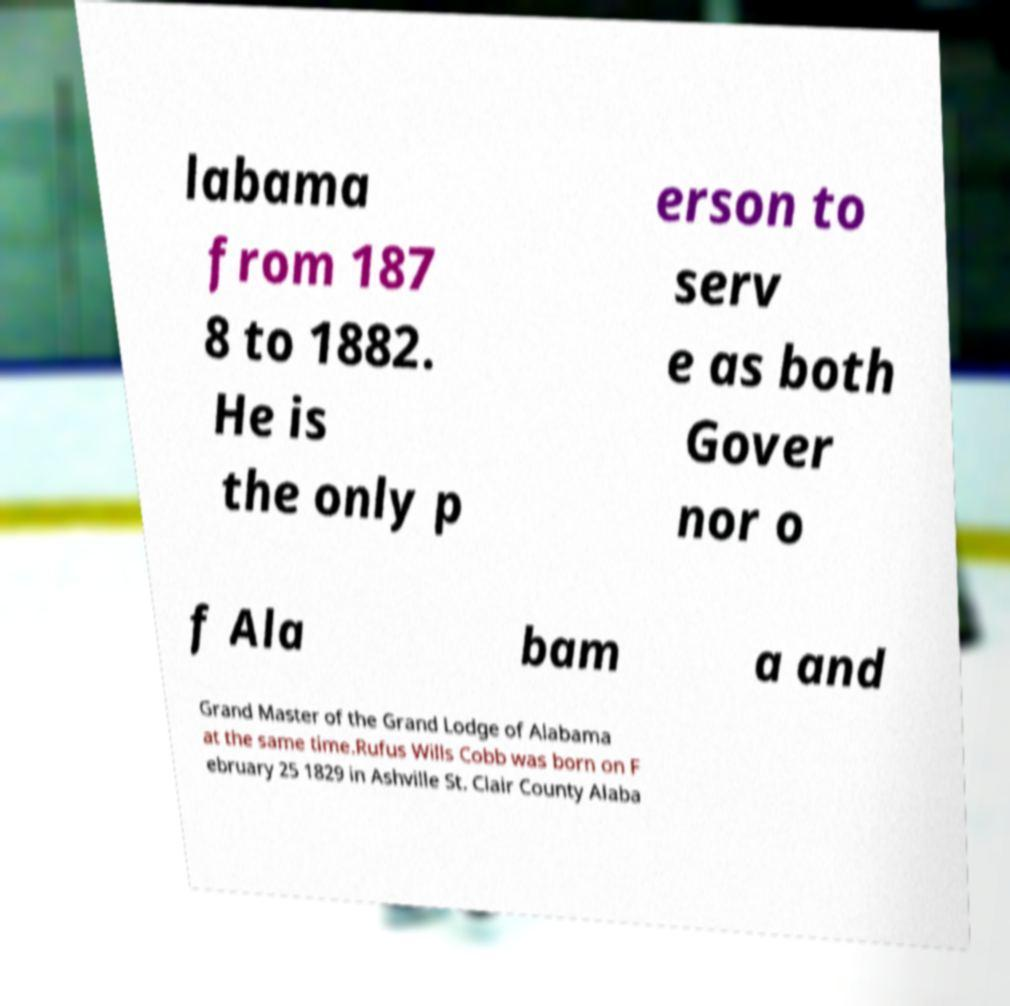Can you read and provide the text displayed in the image?This photo seems to have some interesting text. Can you extract and type it out for me? labama from 187 8 to 1882. He is the only p erson to serv e as both Gover nor o f Ala bam a and Grand Master of the Grand Lodge of Alabama at the same time.Rufus Wills Cobb was born on F ebruary 25 1829 in Ashville St. Clair County Alaba 